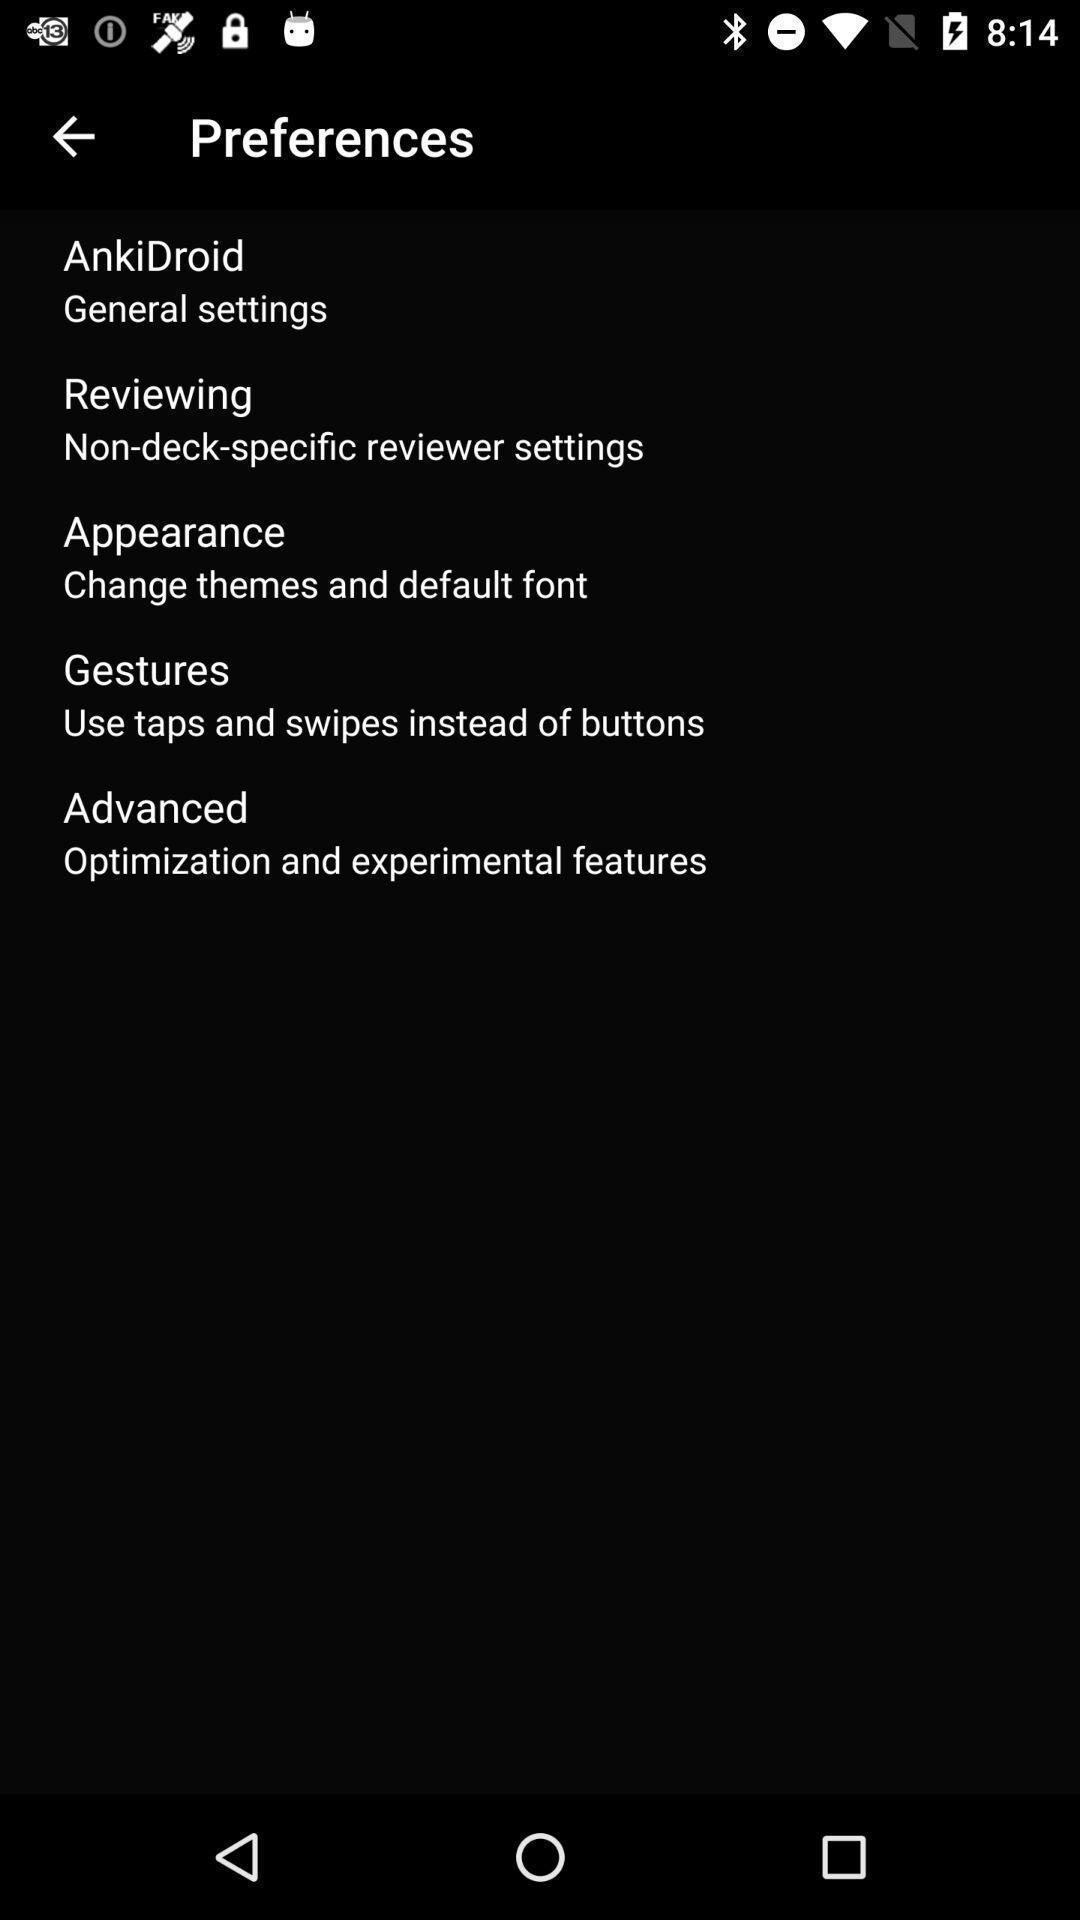What can you discern from this picture? Screen displaying list of settings. 